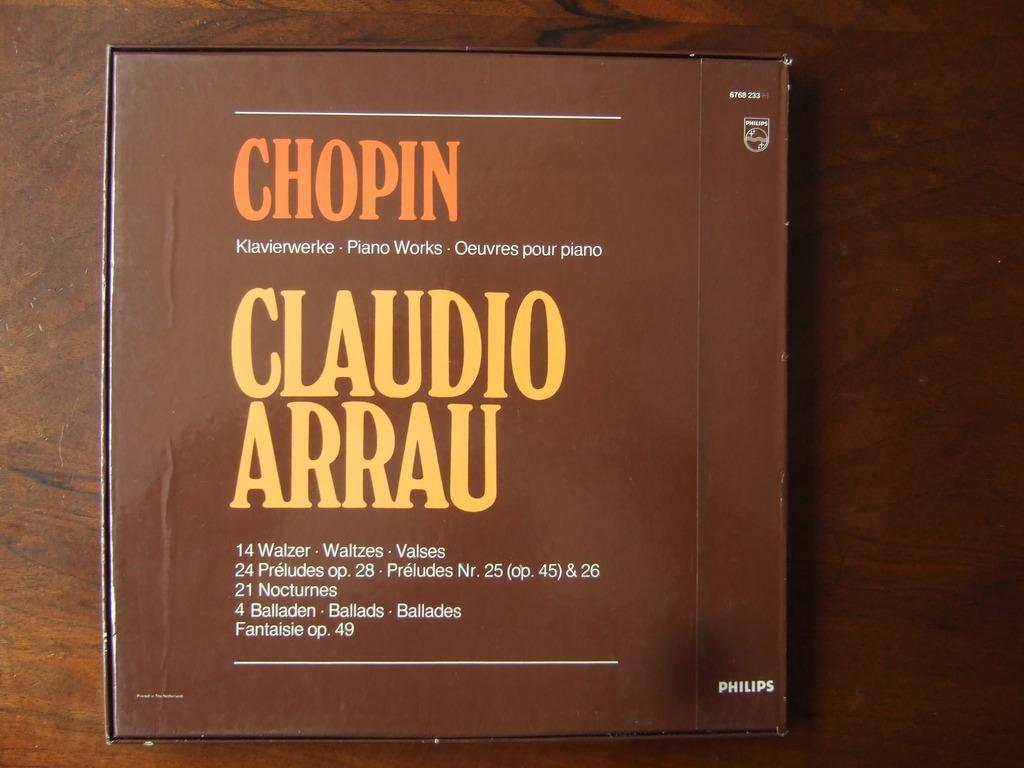Provide a one-sentence caption for the provided image. A box, made by Philips corporation, hold the music of Chopin. 